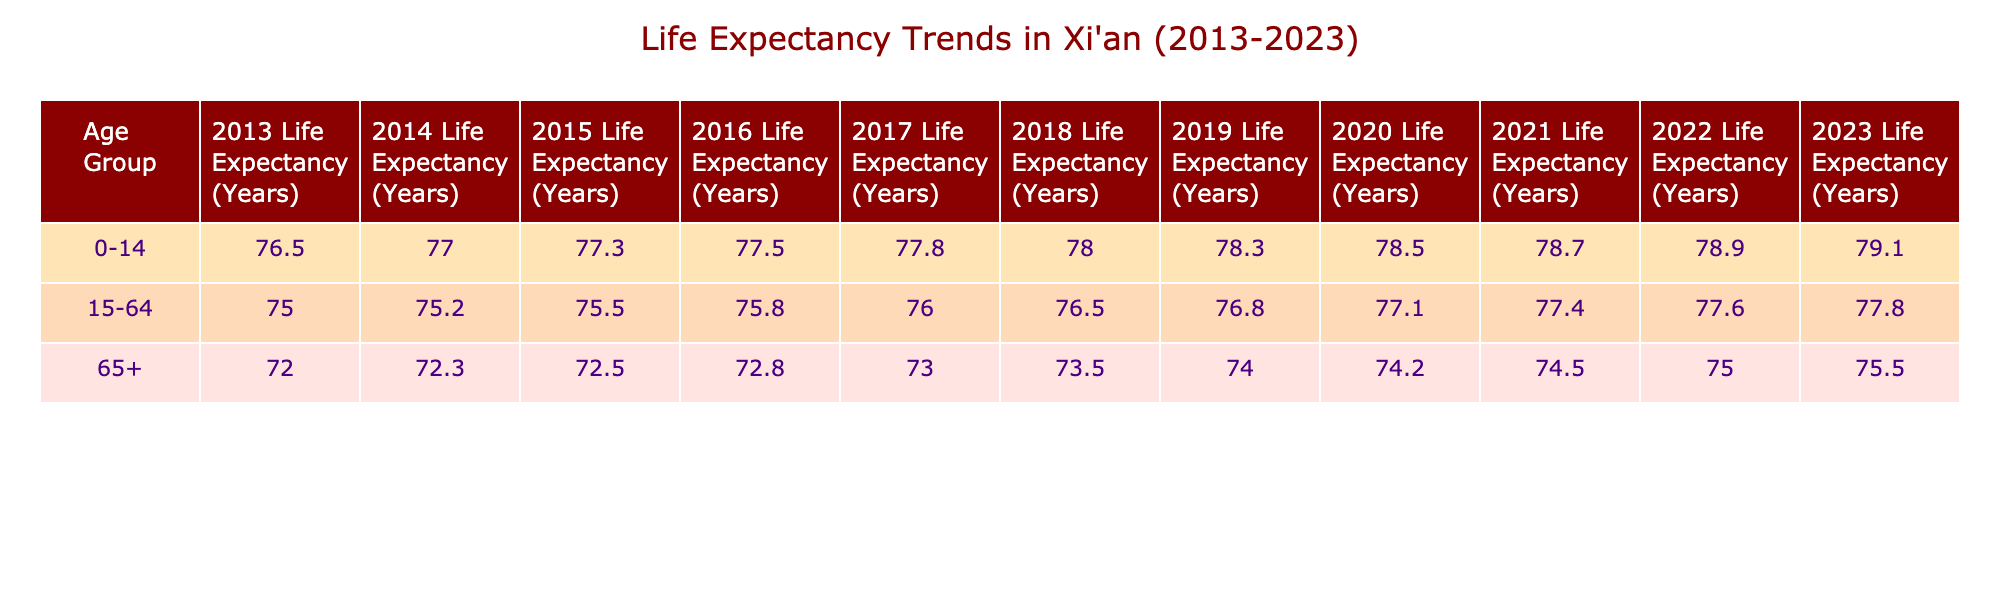What was the life expectancy for the age group 0-14 in 2018? From the table, the life expectancy for the age group 0-14 in 2018 is found in the corresponding row and column; it shows a value of 78.0 years.
Answer: 78.0 What was the life expectancy for the age group 15-64 in 2021? The table indicates that the life expectancy for the age group 15-64 in 2021 is 77.4 years.
Answer: 77.4 Is the life expectancy for the age group 65+ in 2013 greater than the life expectancy for the same age group in 2020? Looking at the table, the life expectancy for the age group 65+ in 2013 is 72.0 years and in 2020 is 74.2 years. Since 72.0 is less than 74.2, the statement is false.
Answer: No What is the difference in life expectancy for the age group 0-14 between 2013 and 2023? The life expectancy for 0-14 in 2013 is 76.5 years and in 2023 is 79.1 years. The difference is calculated as 79.1 - 76.5 = 2.6 years.
Answer: 2.6 What was the average life expectancy for people aged 15-64 from 2013 to 2023? The life expectancies from 2013 to 2023 for age group 15-64 are: 75.0, 75.2, 75.5, 75.8, 76.0, 76.5, 76.8, 77.1, 77.4, 77.6, and 77.8. The sum of these values is 841.8. There are 11 data points, therefore the average is 841.8 / 11 = 76.516, rounding to approximately 76.5 years.
Answer: 76.5 Has the life expectancy for the age group 65+ improved every year from 2013 to 2023? By examining the values for the age group 65+ each year in the table, they are: 72.0, 72.3, 72.5, 72.8, 73.0, 73.5, 74.0, 74.2, 74.5, 75.0, and 75.5. Each year has a higher value than the previous, indicating continuous improvement.
Answer: Yes What was the highest life expectancy recorded in the age group 0-14 from 2013 to 2023? By reviewing the table, the life expectancy for the age group 0-14 over the years is as follows: 76.5, 77.0, 77.3, 77.5, 77.8, 78.0, 78.3, 78.5, 78.7, 78.9, and 79.1. The highest value is thus 79.1 years in 2023.
Answer: 79.1 What was the percentage increase in life expectancy for the age group 15-64 from 2013 to 2023? The life expectancy for 15-64 in 2013 is 75.0 years and in 2023 is 77.8 years. The increase is calculated as (77.8 - 75.0) / 75.0 * 100 = 3.73%.
Answer: 3.73% 